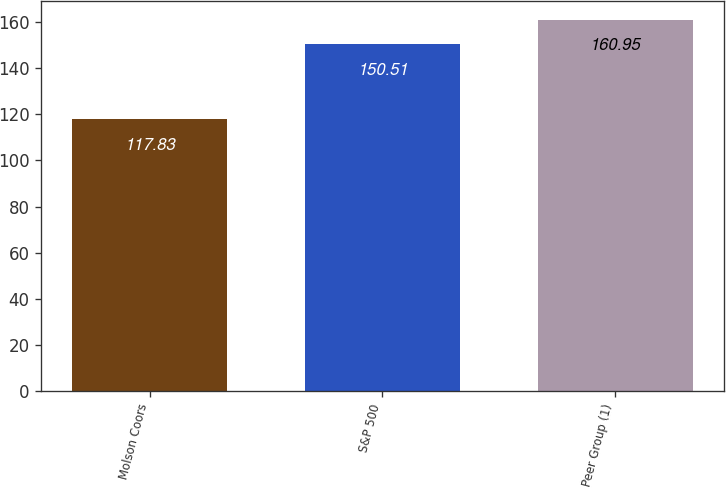Convert chart. <chart><loc_0><loc_0><loc_500><loc_500><bar_chart><fcel>Molson Coors<fcel>S&P 500<fcel>Peer Group (1)<nl><fcel>117.83<fcel>150.51<fcel>160.95<nl></chart> 